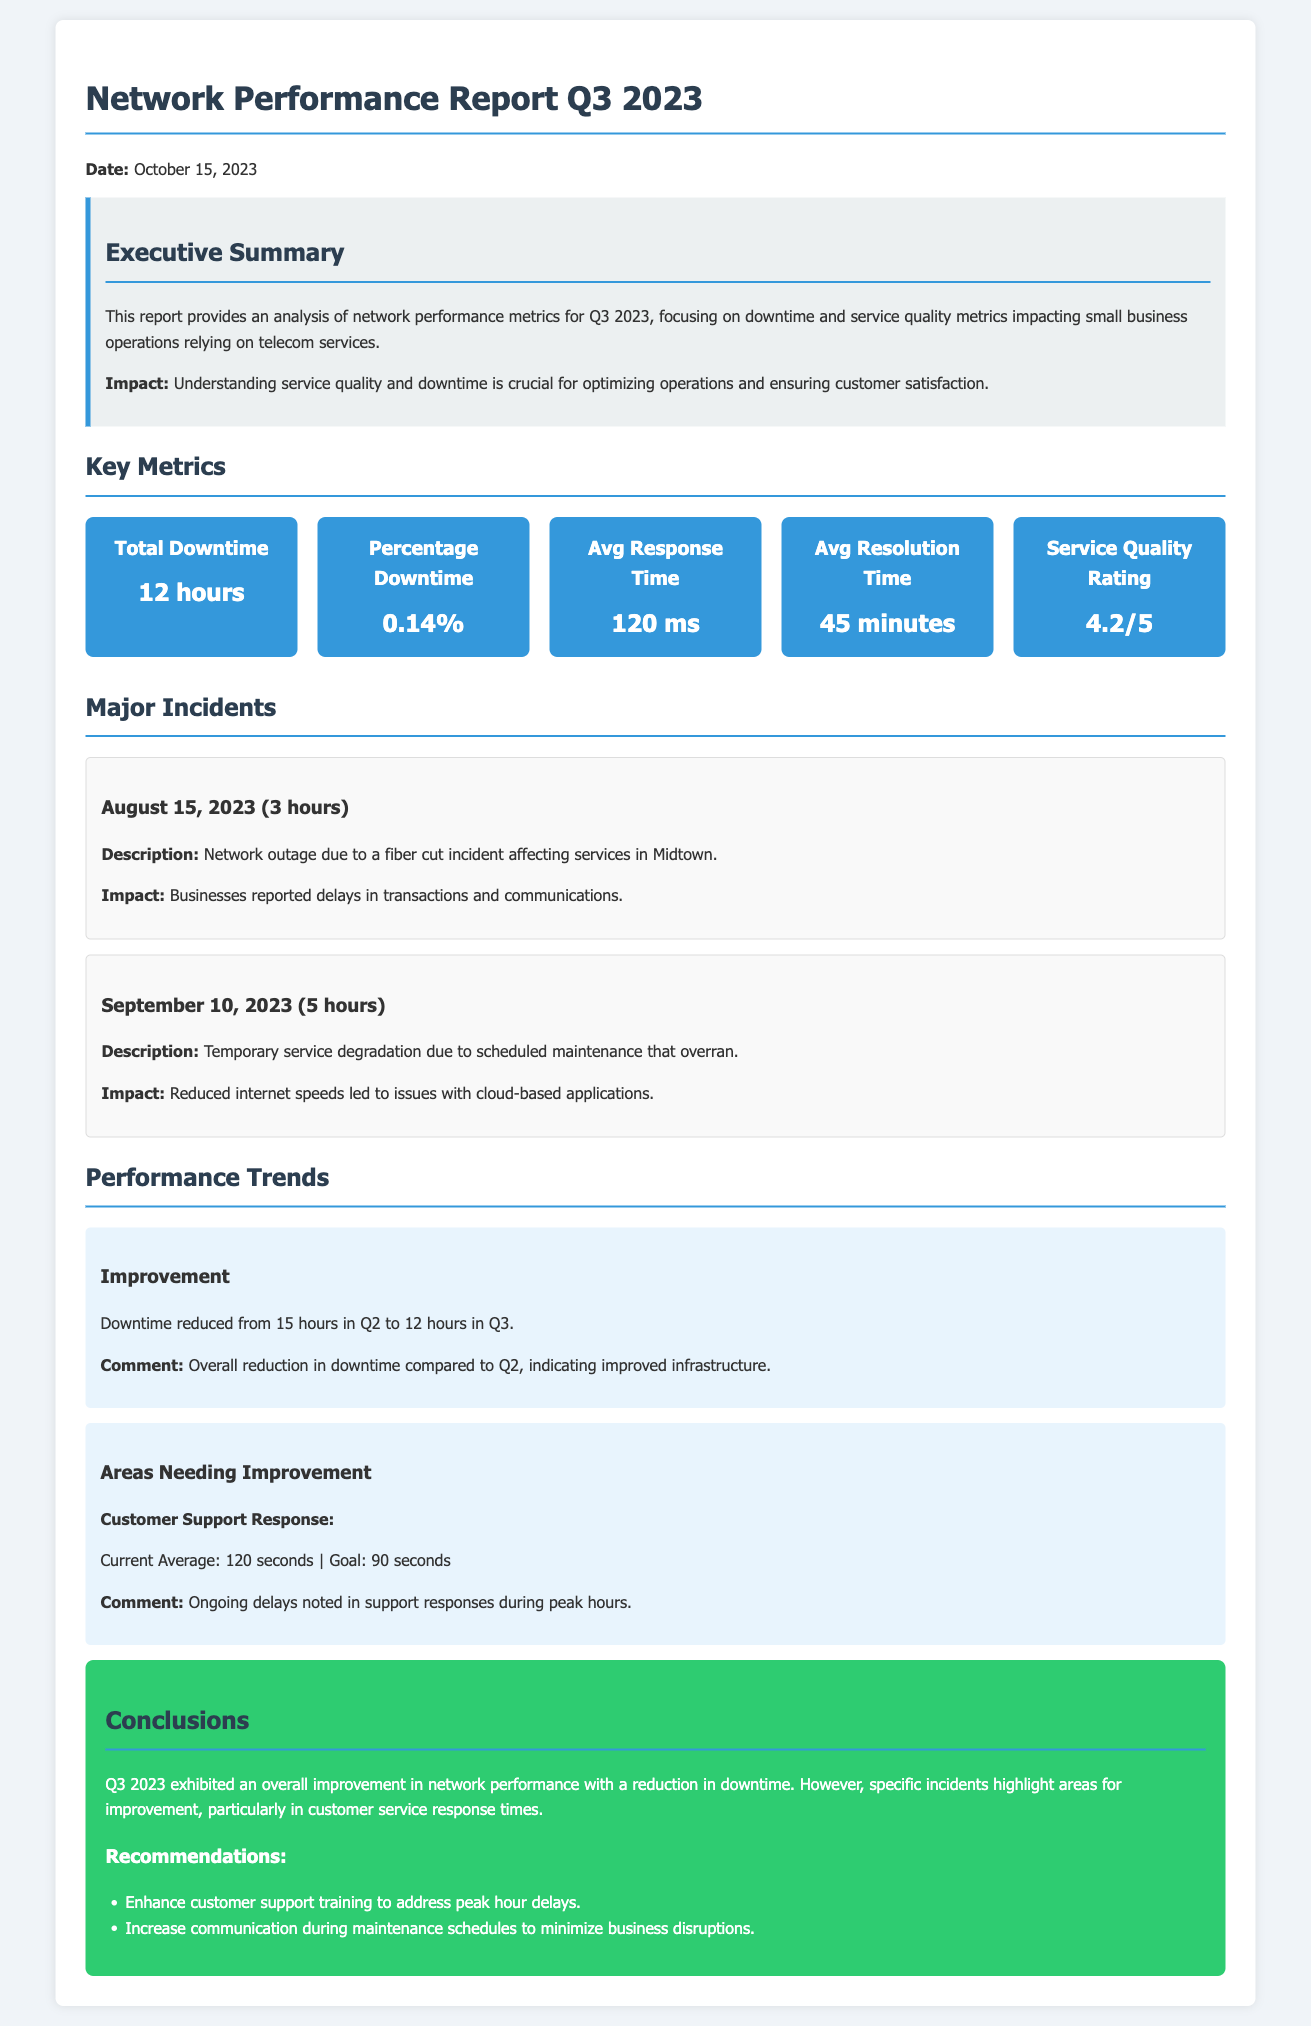what is the total downtime in Q3 2023? The total downtime reported for Q3 2023 is stated in the key metrics section of the document.
Answer: 12 hours what was the service quality rating? The service quality rating provided in the document reflects customer satisfaction on a scale.
Answer: 4.2/5 when did the network outage occur due to a fiber cut incident? The document details the date when the major incident occurred, specifically impacting services.
Answer: August 15, 2023 what was the average resolution time for service issues? The document includes a metric that specifies how long it typically takes to resolve service issues.
Answer: 45 minutes what is the percentage downtime for Q3 2023? The document gives a specific metric related to downtime as a percentage of total service time.
Answer: 0.14% how many hours of downtime were reported in Q2? By reasoning from the performance trend mentioned in the report, we can deduce the downtime from Q2 to Q3.
Answer: 15 hours what was the impact of the September 10, 2023, incident? The document highlights the consequences of a major incident affecting service quality during a specific timeframe.
Answer: Reduced internet speeds led to issues with cloud-based applications what was the average response time for customer support? The document provides a key metric applicable to how quickly support responds to customer inquiries.
Answer: 120 seconds what are the recommendations provided in the conclusion? This question refers to the actionable insights listed in the conclusions section intended to improve service performance.
Answer: Enhance customer support training to address peak hour delays 